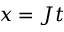Convert formula to latex. <formula><loc_0><loc_0><loc_500><loc_500>x = J t</formula> 